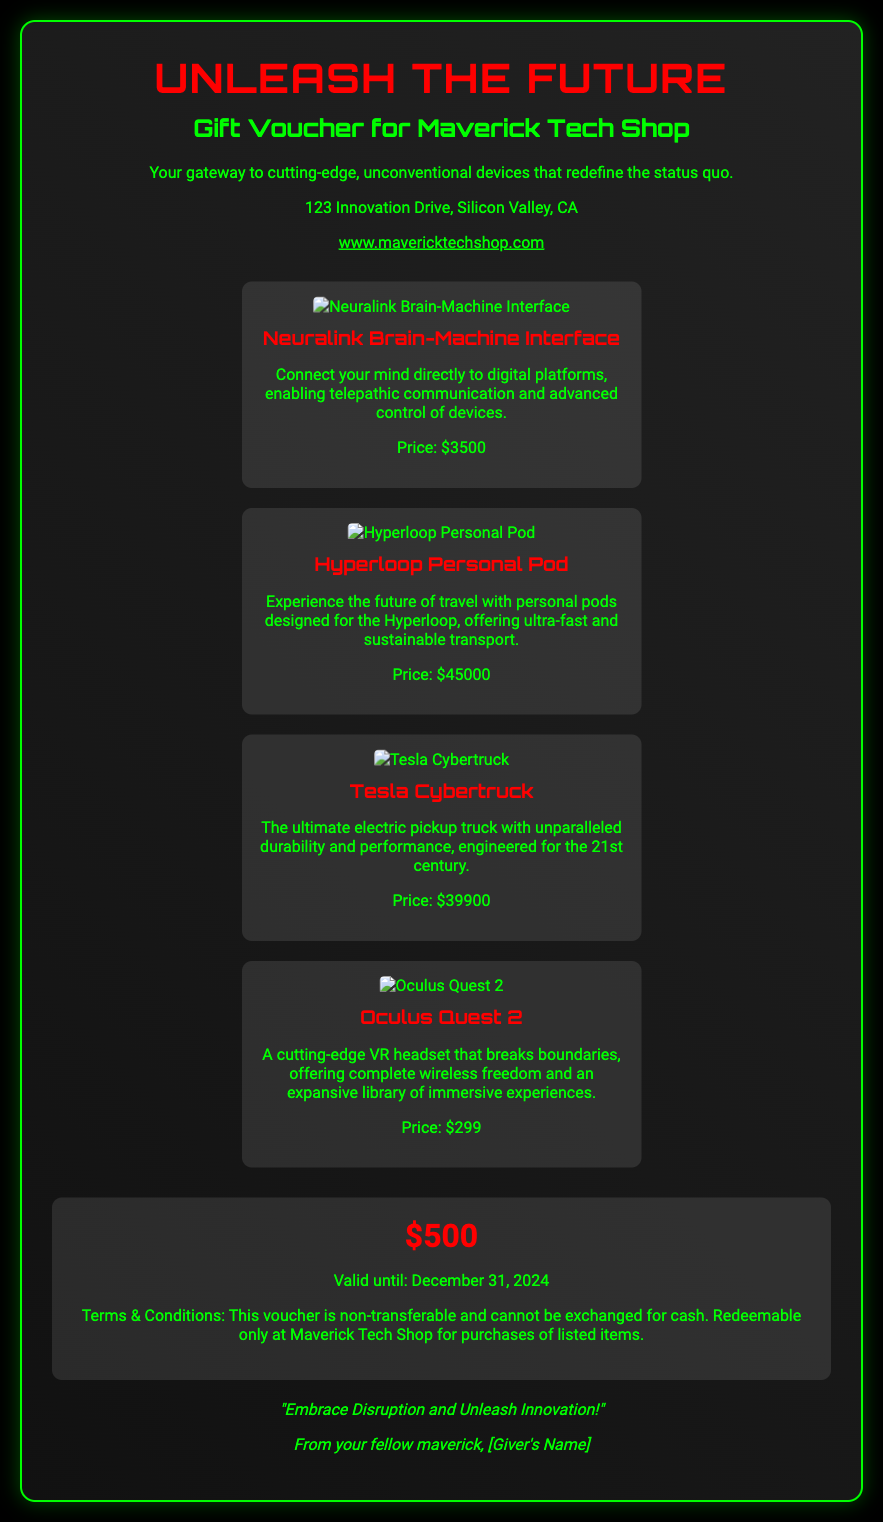What is the value of the gift voucher? The value is explicitly stated in the voucher details section.
Answer: $500 What is the name of the shop for which the voucher is valid? The shop name is mentioned in the header and the shop details.
Answer: Maverick Tech Shop What is the expiration date of the voucher? The expiration date can be found in the voucher details section.
Answer: December 31, 2024 What is a feature of the Neuralink Brain-Machine Interface? The feature is detailed in the description of the product on the voucher.
Answer: Telepathic communication How much does the Hyperloop Personal Pod cost? The cost is listed under the product description.
Answer: $45000 What is one term related to the usage of the voucher? The terms are included in the voucher details section.
Answer: Non-transferable What is the design style of the voucher? The design style is stated in the introductory section of the voucher.
Answer: Modern Who is the voucher from? The giver's name is indicated in the personalization section of the voucher.
Answer: [Giver's Name] What type of products does Maverick Tech Shop specialize in? The specialization is highlighted in the shop details section.
Answer: Cutting-edge, unconventional devices 